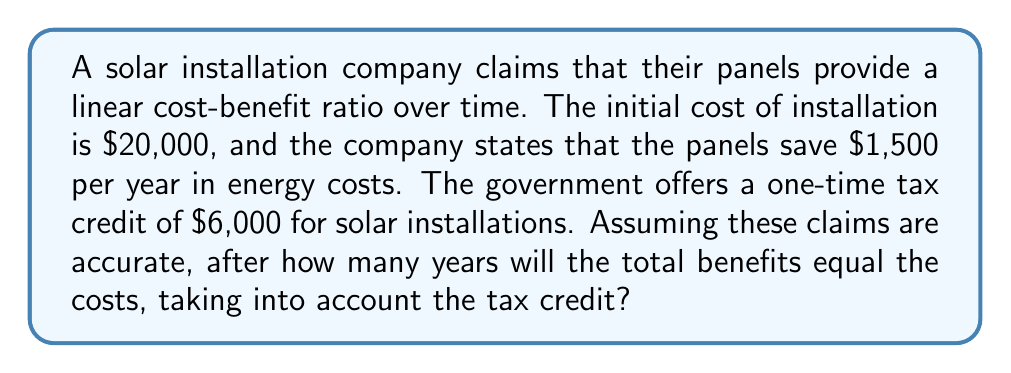Solve this math problem. Let's approach this step-by-step using a linear equation:

1) Let $y$ represent the total benefits and $x$ represent the number of years.

2) The linear equation for benefits over time is:
   $$y = 1500x + 6000$$
   Where 1500x represents the yearly savings, and 6000 is the tax credit.

3) The cost remains constant at $20,000. So we need to find when:
   $$1500x + 6000 = 20000$$

4) Subtract 6000 from both sides:
   $$1500x = 14000$$

5) Divide both sides by 1500:
   $$x = \frac{14000}{1500} = 9.33$$

6) Since we can't have a fraction of a year in this context, we round up to the nearest whole number.

Therefore, it will take 10 years for the benefits to equal the costs.

Note: This calculation assumes the company's claims are accurate and doesn't account for factors such as panel degradation, maintenance costs, or changes in energy prices, which could significantly alter the actual cost-benefit ratio.
Answer: 10 years 